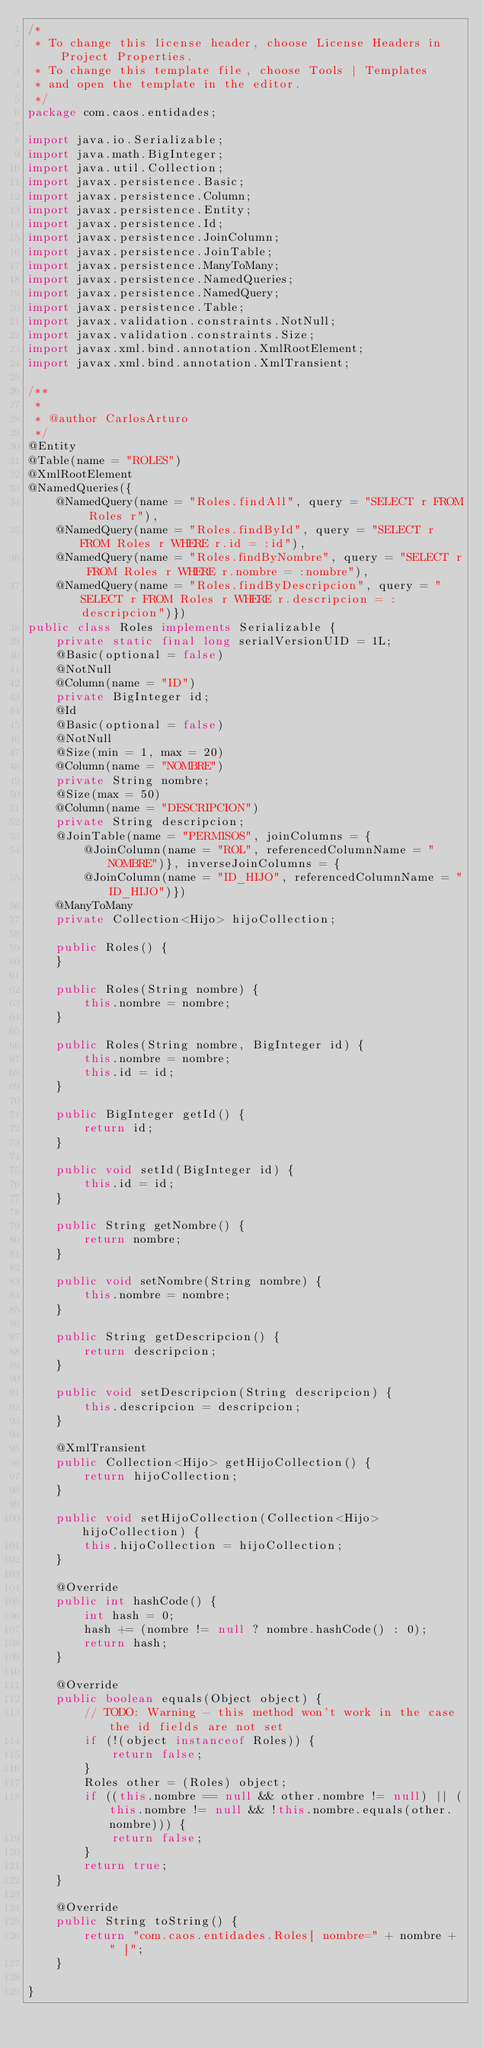Convert code to text. <code><loc_0><loc_0><loc_500><loc_500><_Java_>/*
 * To change this license header, choose License Headers in Project Properties.
 * To change this template file, choose Tools | Templates
 * and open the template in the editor.
 */
package com.caos.entidades;

import java.io.Serializable;
import java.math.BigInteger;
import java.util.Collection;
import javax.persistence.Basic;
import javax.persistence.Column;
import javax.persistence.Entity;
import javax.persistence.Id;
import javax.persistence.JoinColumn;
import javax.persistence.JoinTable;
import javax.persistence.ManyToMany;
import javax.persistence.NamedQueries;
import javax.persistence.NamedQuery;
import javax.persistence.Table;
import javax.validation.constraints.NotNull;
import javax.validation.constraints.Size;
import javax.xml.bind.annotation.XmlRootElement;
import javax.xml.bind.annotation.XmlTransient;

/**
 *
 * @author CarlosArturo
 */
@Entity
@Table(name = "ROLES")
@XmlRootElement
@NamedQueries({
    @NamedQuery(name = "Roles.findAll", query = "SELECT r FROM Roles r"),
    @NamedQuery(name = "Roles.findById", query = "SELECT r FROM Roles r WHERE r.id = :id"),
    @NamedQuery(name = "Roles.findByNombre", query = "SELECT r FROM Roles r WHERE r.nombre = :nombre"),
    @NamedQuery(name = "Roles.findByDescripcion", query = "SELECT r FROM Roles r WHERE r.descripcion = :descripcion")})
public class Roles implements Serializable {
    private static final long serialVersionUID = 1L;
    @Basic(optional = false)
    @NotNull
    @Column(name = "ID")
    private BigInteger id;
    @Id
    @Basic(optional = false)
    @NotNull
    @Size(min = 1, max = 20)
    @Column(name = "NOMBRE")
    private String nombre;
    @Size(max = 50)
    @Column(name = "DESCRIPCION")
    private String descripcion;
    @JoinTable(name = "PERMISOS", joinColumns = {
        @JoinColumn(name = "ROL", referencedColumnName = "NOMBRE")}, inverseJoinColumns = {
        @JoinColumn(name = "ID_HIJO", referencedColumnName = "ID_HIJO")})
    @ManyToMany
    private Collection<Hijo> hijoCollection;

    public Roles() {
    }

    public Roles(String nombre) {
        this.nombre = nombre;
    }

    public Roles(String nombre, BigInteger id) {
        this.nombre = nombre;
        this.id = id;
    }

    public BigInteger getId() {
        return id;
    }

    public void setId(BigInteger id) {
        this.id = id;
    }

    public String getNombre() {
        return nombre;
    }

    public void setNombre(String nombre) {
        this.nombre = nombre;
    }

    public String getDescripcion() {
        return descripcion;
    }

    public void setDescripcion(String descripcion) {
        this.descripcion = descripcion;
    }

    @XmlTransient
    public Collection<Hijo> getHijoCollection() {
        return hijoCollection;
    }

    public void setHijoCollection(Collection<Hijo> hijoCollection) {
        this.hijoCollection = hijoCollection;
    }

    @Override
    public int hashCode() {
        int hash = 0;
        hash += (nombre != null ? nombre.hashCode() : 0);
        return hash;
    }

    @Override
    public boolean equals(Object object) {
        // TODO: Warning - this method won't work in the case the id fields are not set
        if (!(object instanceof Roles)) {
            return false;
        }
        Roles other = (Roles) object;
        if ((this.nombre == null && other.nombre != null) || (this.nombre != null && !this.nombre.equals(other.nombre))) {
            return false;
        }
        return true;
    }

    @Override
    public String toString() {
        return "com.caos.entidades.Roles[ nombre=" + nombre + " ]";
    }

}
</code> 